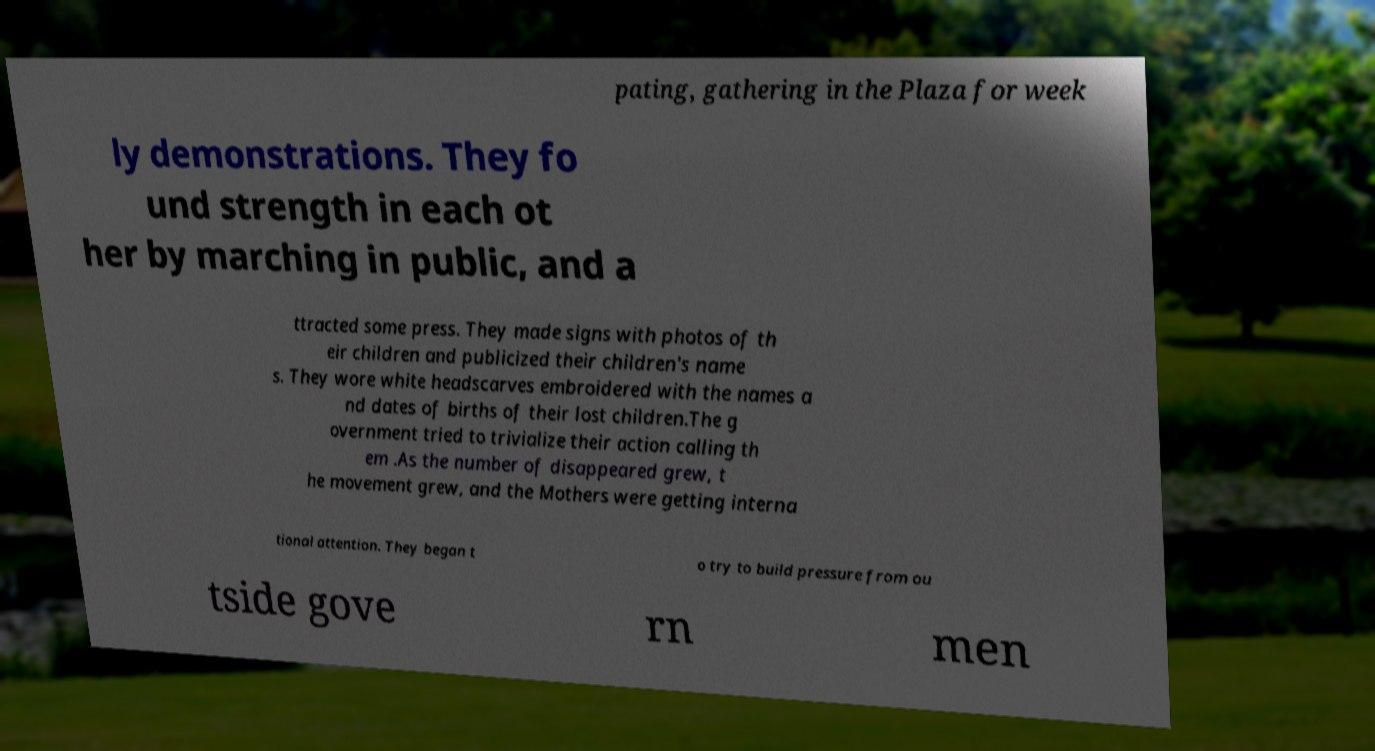Could you extract and type out the text from this image? pating, gathering in the Plaza for week ly demonstrations. They fo und strength in each ot her by marching in public, and a ttracted some press. They made signs with photos of th eir children and publicized their children's name s. They wore white headscarves embroidered with the names a nd dates of births of their lost children.The g overnment tried to trivialize their action calling th em .As the number of disappeared grew, t he movement grew, and the Mothers were getting interna tional attention. They began t o try to build pressure from ou tside gove rn men 